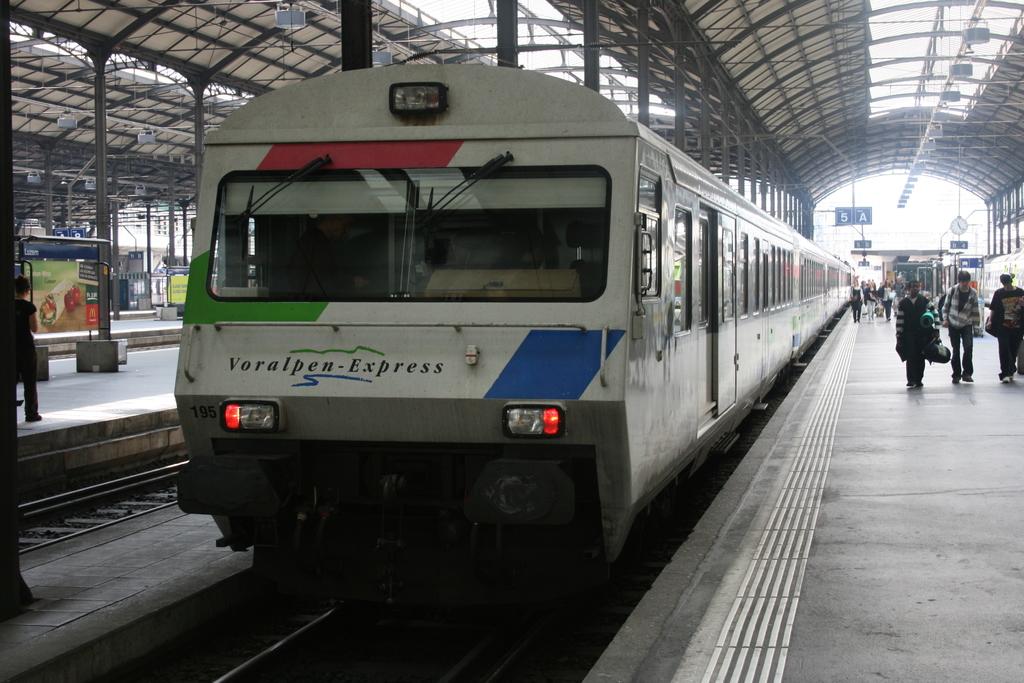What is the name of this train?
Make the answer very short. Voralpen-express. 